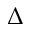<formula> <loc_0><loc_0><loc_500><loc_500>\Delta</formula> 